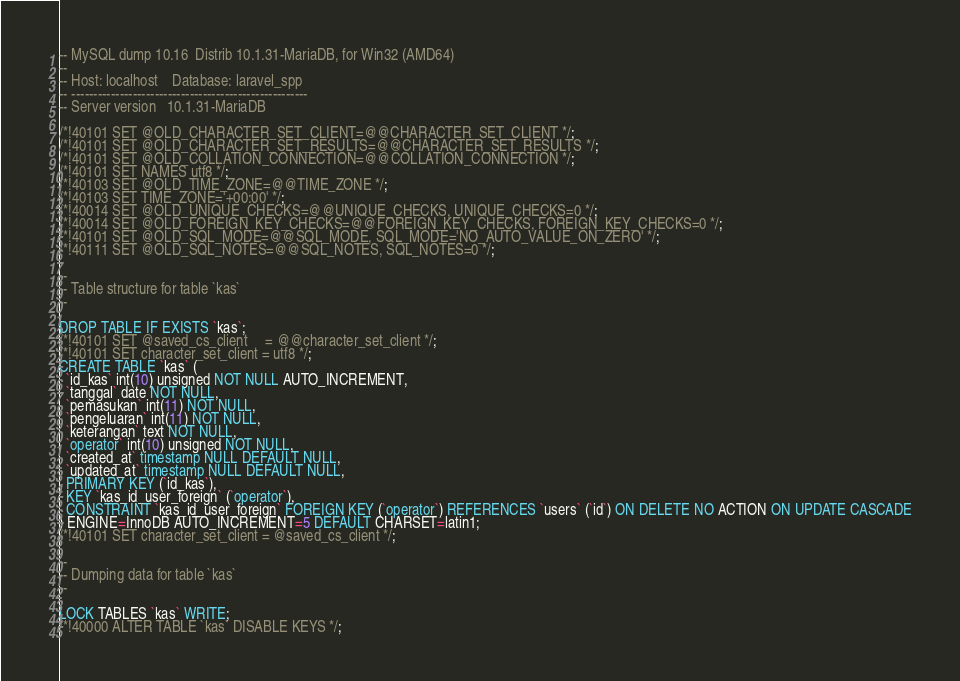Convert code to text. <code><loc_0><loc_0><loc_500><loc_500><_SQL_>-- MySQL dump 10.16  Distrib 10.1.31-MariaDB, for Win32 (AMD64)
--
-- Host: localhost    Database: laravel_spp
-- ------------------------------------------------------
-- Server version	10.1.31-MariaDB

/*!40101 SET @OLD_CHARACTER_SET_CLIENT=@@CHARACTER_SET_CLIENT */;
/*!40101 SET @OLD_CHARACTER_SET_RESULTS=@@CHARACTER_SET_RESULTS */;
/*!40101 SET @OLD_COLLATION_CONNECTION=@@COLLATION_CONNECTION */;
/*!40101 SET NAMES utf8 */;
/*!40103 SET @OLD_TIME_ZONE=@@TIME_ZONE */;
/*!40103 SET TIME_ZONE='+00:00' */;
/*!40014 SET @OLD_UNIQUE_CHECKS=@@UNIQUE_CHECKS, UNIQUE_CHECKS=0 */;
/*!40014 SET @OLD_FOREIGN_KEY_CHECKS=@@FOREIGN_KEY_CHECKS, FOREIGN_KEY_CHECKS=0 */;
/*!40101 SET @OLD_SQL_MODE=@@SQL_MODE, SQL_MODE='NO_AUTO_VALUE_ON_ZERO' */;
/*!40111 SET @OLD_SQL_NOTES=@@SQL_NOTES, SQL_NOTES=0 */;

--
-- Table structure for table `kas`
--

DROP TABLE IF EXISTS `kas`;
/*!40101 SET @saved_cs_client     = @@character_set_client */;
/*!40101 SET character_set_client = utf8 */;
CREATE TABLE `kas` (
  `id_kas` int(10) unsigned NOT NULL AUTO_INCREMENT,
  `tanggal` date NOT NULL,
  `pemasukan` int(11) NOT NULL,
  `pengeluaran` int(11) NOT NULL,
  `keterangan` text NOT NULL,
  `operator` int(10) unsigned NOT NULL,
  `created_at` timestamp NULL DEFAULT NULL,
  `updated_at` timestamp NULL DEFAULT NULL,
  PRIMARY KEY (`id_kas`),
  KEY `kas_id_user_foreign` (`operator`),
  CONSTRAINT `kas_id_user_foreign` FOREIGN KEY (`operator`) REFERENCES `users` (`id`) ON DELETE NO ACTION ON UPDATE CASCADE
) ENGINE=InnoDB AUTO_INCREMENT=5 DEFAULT CHARSET=latin1;
/*!40101 SET character_set_client = @saved_cs_client */;

--
-- Dumping data for table `kas`
--

LOCK TABLES `kas` WRITE;
/*!40000 ALTER TABLE `kas` DISABLE KEYS */;</code> 